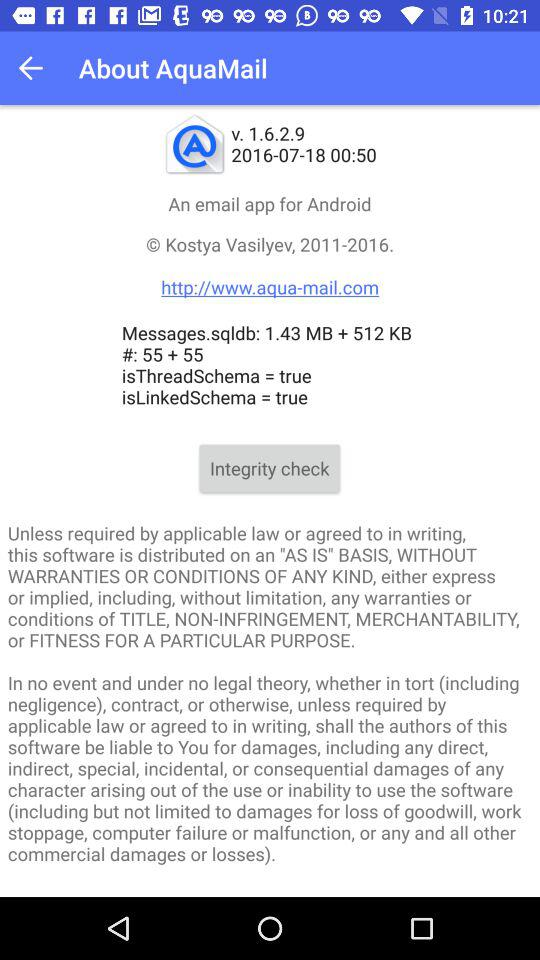What is the app name? The app name is "AquaMail". 